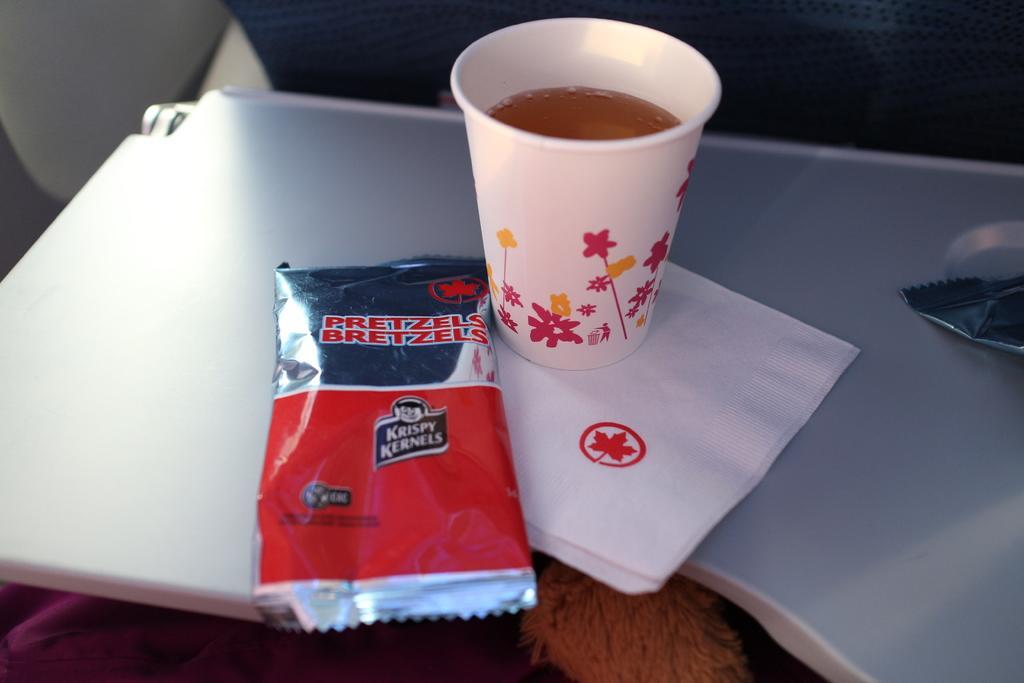Please provide a concise description of this image. In the foreground of this image, there is a sachet, tissue and a cup on a table. We can also see another sachet on the right. 